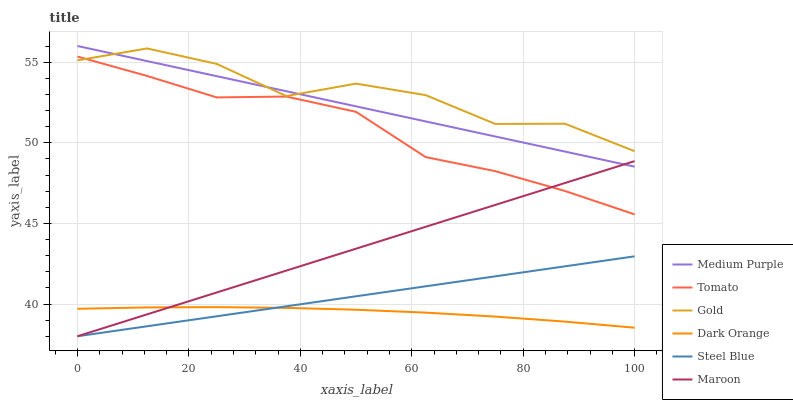Does Dark Orange have the minimum area under the curve?
Answer yes or no. Yes. Does Gold have the maximum area under the curve?
Answer yes or no. Yes. Does Gold have the minimum area under the curve?
Answer yes or no. No. Does Dark Orange have the maximum area under the curve?
Answer yes or no. No. Is Steel Blue the smoothest?
Answer yes or no. Yes. Is Gold the roughest?
Answer yes or no. Yes. Is Dark Orange the smoothest?
Answer yes or no. No. Is Dark Orange the roughest?
Answer yes or no. No. Does Dark Orange have the lowest value?
Answer yes or no. No. Does Gold have the highest value?
Answer yes or no. No. Is Steel Blue less than Medium Purple?
Answer yes or no. Yes. Is Tomato greater than Dark Orange?
Answer yes or no. Yes. Does Steel Blue intersect Medium Purple?
Answer yes or no. No. 